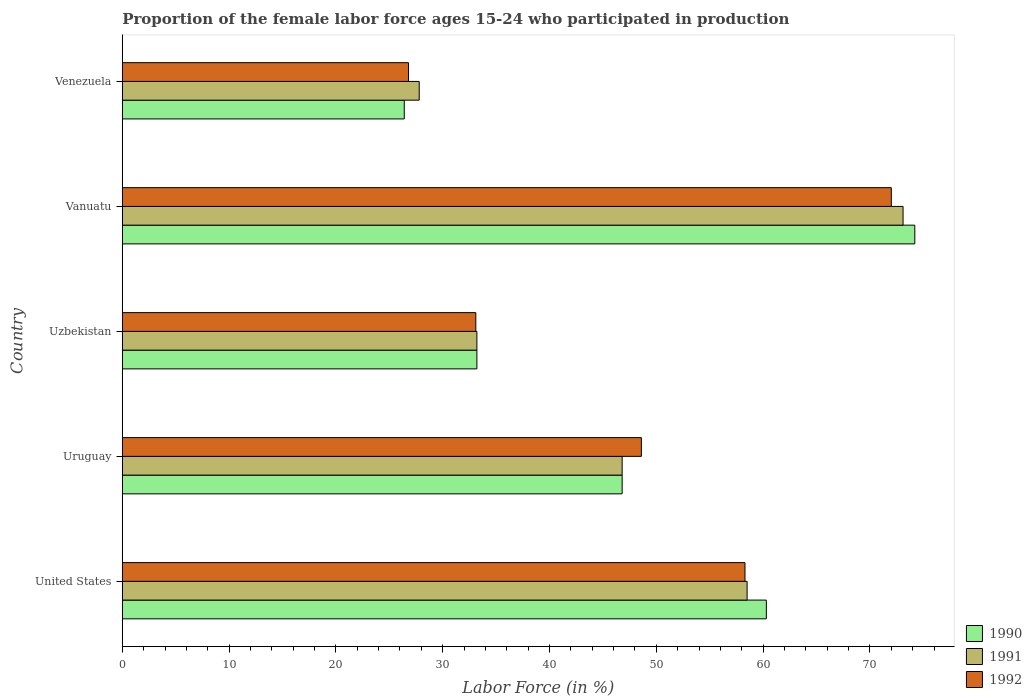Are the number of bars on each tick of the Y-axis equal?
Provide a short and direct response. Yes. How many bars are there on the 4th tick from the bottom?
Ensure brevity in your answer.  3. What is the label of the 4th group of bars from the top?
Your response must be concise. Uruguay. What is the proportion of the female labor force who participated in production in 1992 in Uzbekistan?
Provide a succinct answer. 33.1. Across all countries, what is the maximum proportion of the female labor force who participated in production in 1990?
Ensure brevity in your answer.  74.2. Across all countries, what is the minimum proportion of the female labor force who participated in production in 1992?
Provide a short and direct response. 26.8. In which country was the proportion of the female labor force who participated in production in 1992 maximum?
Provide a succinct answer. Vanuatu. In which country was the proportion of the female labor force who participated in production in 1992 minimum?
Your answer should be very brief. Venezuela. What is the total proportion of the female labor force who participated in production in 1991 in the graph?
Offer a terse response. 239.4. What is the difference between the proportion of the female labor force who participated in production in 1991 in Vanuatu and that in Venezuela?
Your answer should be compact. 45.3. What is the difference between the proportion of the female labor force who participated in production in 1992 in United States and the proportion of the female labor force who participated in production in 1991 in Venezuela?
Offer a terse response. 30.5. What is the average proportion of the female labor force who participated in production in 1992 per country?
Make the answer very short. 47.76. What is the difference between the proportion of the female labor force who participated in production in 1991 and proportion of the female labor force who participated in production in 1992 in Uzbekistan?
Your answer should be compact. 0.1. In how many countries, is the proportion of the female labor force who participated in production in 1991 greater than 60 %?
Offer a terse response. 1. What is the ratio of the proportion of the female labor force who participated in production in 1991 in Uruguay to that in Vanuatu?
Your answer should be very brief. 0.64. Is the difference between the proportion of the female labor force who participated in production in 1991 in Uruguay and Venezuela greater than the difference between the proportion of the female labor force who participated in production in 1992 in Uruguay and Venezuela?
Ensure brevity in your answer.  No. What is the difference between the highest and the second highest proportion of the female labor force who participated in production in 1991?
Offer a terse response. 14.6. What is the difference between the highest and the lowest proportion of the female labor force who participated in production in 1992?
Provide a succinct answer. 45.2. In how many countries, is the proportion of the female labor force who participated in production in 1992 greater than the average proportion of the female labor force who participated in production in 1992 taken over all countries?
Ensure brevity in your answer.  3. Is the sum of the proportion of the female labor force who participated in production in 1992 in Uruguay and Vanuatu greater than the maximum proportion of the female labor force who participated in production in 1990 across all countries?
Provide a short and direct response. Yes. Is it the case that in every country, the sum of the proportion of the female labor force who participated in production in 1990 and proportion of the female labor force who participated in production in 1992 is greater than the proportion of the female labor force who participated in production in 1991?
Your answer should be very brief. Yes. How many bars are there?
Your answer should be very brief. 15. How many countries are there in the graph?
Keep it short and to the point. 5. Does the graph contain grids?
Make the answer very short. No. Where does the legend appear in the graph?
Give a very brief answer. Bottom right. How many legend labels are there?
Your answer should be compact. 3. How are the legend labels stacked?
Your answer should be very brief. Vertical. What is the title of the graph?
Offer a very short reply. Proportion of the female labor force ages 15-24 who participated in production. Does "1998" appear as one of the legend labels in the graph?
Give a very brief answer. No. What is the label or title of the X-axis?
Ensure brevity in your answer.  Labor Force (in %). What is the Labor Force (in %) in 1990 in United States?
Ensure brevity in your answer.  60.3. What is the Labor Force (in %) in 1991 in United States?
Provide a succinct answer. 58.5. What is the Labor Force (in %) of 1992 in United States?
Provide a succinct answer. 58.3. What is the Labor Force (in %) of 1990 in Uruguay?
Ensure brevity in your answer.  46.8. What is the Labor Force (in %) of 1991 in Uruguay?
Keep it short and to the point. 46.8. What is the Labor Force (in %) in 1992 in Uruguay?
Keep it short and to the point. 48.6. What is the Labor Force (in %) in 1990 in Uzbekistan?
Make the answer very short. 33.2. What is the Labor Force (in %) in 1991 in Uzbekistan?
Provide a short and direct response. 33.2. What is the Labor Force (in %) of 1992 in Uzbekistan?
Provide a succinct answer. 33.1. What is the Labor Force (in %) in 1990 in Vanuatu?
Your response must be concise. 74.2. What is the Labor Force (in %) in 1991 in Vanuatu?
Ensure brevity in your answer.  73.1. What is the Labor Force (in %) in 1990 in Venezuela?
Make the answer very short. 26.4. What is the Labor Force (in %) of 1991 in Venezuela?
Provide a succinct answer. 27.8. What is the Labor Force (in %) of 1992 in Venezuela?
Make the answer very short. 26.8. Across all countries, what is the maximum Labor Force (in %) of 1990?
Your answer should be compact. 74.2. Across all countries, what is the maximum Labor Force (in %) in 1991?
Keep it short and to the point. 73.1. Across all countries, what is the maximum Labor Force (in %) of 1992?
Give a very brief answer. 72. Across all countries, what is the minimum Labor Force (in %) in 1990?
Make the answer very short. 26.4. Across all countries, what is the minimum Labor Force (in %) in 1991?
Give a very brief answer. 27.8. Across all countries, what is the minimum Labor Force (in %) of 1992?
Offer a terse response. 26.8. What is the total Labor Force (in %) of 1990 in the graph?
Give a very brief answer. 240.9. What is the total Labor Force (in %) in 1991 in the graph?
Offer a terse response. 239.4. What is the total Labor Force (in %) in 1992 in the graph?
Your answer should be very brief. 238.8. What is the difference between the Labor Force (in %) of 1991 in United States and that in Uruguay?
Provide a short and direct response. 11.7. What is the difference between the Labor Force (in %) in 1992 in United States and that in Uruguay?
Provide a short and direct response. 9.7. What is the difference between the Labor Force (in %) of 1990 in United States and that in Uzbekistan?
Your answer should be very brief. 27.1. What is the difference between the Labor Force (in %) of 1991 in United States and that in Uzbekistan?
Give a very brief answer. 25.3. What is the difference between the Labor Force (in %) of 1992 in United States and that in Uzbekistan?
Your response must be concise. 25.2. What is the difference between the Labor Force (in %) in 1991 in United States and that in Vanuatu?
Your answer should be compact. -14.6. What is the difference between the Labor Force (in %) in 1992 in United States and that in Vanuatu?
Your answer should be compact. -13.7. What is the difference between the Labor Force (in %) of 1990 in United States and that in Venezuela?
Your response must be concise. 33.9. What is the difference between the Labor Force (in %) in 1991 in United States and that in Venezuela?
Offer a very short reply. 30.7. What is the difference between the Labor Force (in %) of 1992 in United States and that in Venezuela?
Your answer should be compact. 31.5. What is the difference between the Labor Force (in %) of 1990 in Uruguay and that in Uzbekistan?
Your response must be concise. 13.6. What is the difference between the Labor Force (in %) in 1991 in Uruguay and that in Uzbekistan?
Provide a succinct answer. 13.6. What is the difference between the Labor Force (in %) of 1992 in Uruguay and that in Uzbekistan?
Offer a very short reply. 15.5. What is the difference between the Labor Force (in %) of 1990 in Uruguay and that in Vanuatu?
Keep it short and to the point. -27.4. What is the difference between the Labor Force (in %) of 1991 in Uruguay and that in Vanuatu?
Offer a very short reply. -26.3. What is the difference between the Labor Force (in %) of 1992 in Uruguay and that in Vanuatu?
Provide a short and direct response. -23.4. What is the difference between the Labor Force (in %) in 1990 in Uruguay and that in Venezuela?
Your response must be concise. 20.4. What is the difference between the Labor Force (in %) of 1991 in Uruguay and that in Venezuela?
Your response must be concise. 19. What is the difference between the Labor Force (in %) in 1992 in Uruguay and that in Venezuela?
Give a very brief answer. 21.8. What is the difference between the Labor Force (in %) of 1990 in Uzbekistan and that in Vanuatu?
Your response must be concise. -41. What is the difference between the Labor Force (in %) in 1991 in Uzbekistan and that in Vanuatu?
Your answer should be very brief. -39.9. What is the difference between the Labor Force (in %) in 1992 in Uzbekistan and that in Vanuatu?
Provide a succinct answer. -38.9. What is the difference between the Labor Force (in %) of 1991 in Uzbekistan and that in Venezuela?
Provide a short and direct response. 5.4. What is the difference between the Labor Force (in %) of 1992 in Uzbekistan and that in Venezuela?
Ensure brevity in your answer.  6.3. What is the difference between the Labor Force (in %) of 1990 in Vanuatu and that in Venezuela?
Make the answer very short. 47.8. What is the difference between the Labor Force (in %) of 1991 in Vanuatu and that in Venezuela?
Make the answer very short. 45.3. What is the difference between the Labor Force (in %) of 1992 in Vanuatu and that in Venezuela?
Offer a terse response. 45.2. What is the difference between the Labor Force (in %) of 1991 in United States and the Labor Force (in %) of 1992 in Uruguay?
Make the answer very short. 9.9. What is the difference between the Labor Force (in %) of 1990 in United States and the Labor Force (in %) of 1991 in Uzbekistan?
Offer a terse response. 27.1. What is the difference between the Labor Force (in %) in 1990 in United States and the Labor Force (in %) in 1992 in Uzbekistan?
Offer a very short reply. 27.2. What is the difference between the Labor Force (in %) in 1991 in United States and the Labor Force (in %) in 1992 in Uzbekistan?
Ensure brevity in your answer.  25.4. What is the difference between the Labor Force (in %) in 1990 in United States and the Labor Force (in %) in 1991 in Venezuela?
Your answer should be compact. 32.5. What is the difference between the Labor Force (in %) in 1990 in United States and the Labor Force (in %) in 1992 in Venezuela?
Provide a short and direct response. 33.5. What is the difference between the Labor Force (in %) of 1991 in United States and the Labor Force (in %) of 1992 in Venezuela?
Your response must be concise. 31.7. What is the difference between the Labor Force (in %) of 1990 in Uruguay and the Labor Force (in %) of 1991 in Uzbekistan?
Offer a terse response. 13.6. What is the difference between the Labor Force (in %) in 1990 in Uruguay and the Labor Force (in %) in 1991 in Vanuatu?
Ensure brevity in your answer.  -26.3. What is the difference between the Labor Force (in %) of 1990 in Uruguay and the Labor Force (in %) of 1992 in Vanuatu?
Offer a terse response. -25.2. What is the difference between the Labor Force (in %) in 1991 in Uruguay and the Labor Force (in %) in 1992 in Vanuatu?
Your response must be concise. -25.2. What is the difference between the Labor Force (in %) in 1990 in Uruguay and the Labor Force (in %) in 1991 in Venezuela?
Your answer should be compact. 19. What is the difference between the Labor Force (in %) of 1990 in Uruguay and the Labor Force (in %) of 1992 in Venezuela?
Provide a short and direct response. 20. What is the difference between the Labor Force (in %) in 1990 in Uzbekistan and the Labor Force (in %) in 1991 in Vanuatu?
Provide a succinct answer. -39.9. What is the difference between the Labor Force (in %) of 1990 in Uzbekistan and the Labor Force (in %) of 1992 in Vanuatu?
Your response must be concise. -38.8. What is the difference between the Labor Force (in %) in 1991 in Uzbekistan and the Labor Force (in %) in 1992 in Vanuatu?
Your response must be concise. -38.8. What is the difference between the Labor Force (in %) of 1990 in Uzbekistan and the Labor Force (in %) of 1992 in Venezuela?
Keep it short and to the point. 6.4. What is the difference between the Labor Force (in %) of 1990 in Vanuatu and the Labor Force (in %) of 1991 in Venezuela?
Offer a terse response. 46.4. What is the difference between the Labor Force (in %) in 1990 in Vanuatu and the Labor Force (in %) in 1992 in Venezuela?
Your answer should be very brief. 47.4. What is the difference between the Labor Force (in %) of 1991 in Vanuatu and the Labor Force (in %) of 1992 in Venezuela?
Make the answer very short. 46.3. What is the average Labor Force (in %) of 1990 per country?
Provide a short and direct response. 48.18. What is the average Labor Force (in %) in 1991 per country?
Your answer should be compact. 47.88. What is the average Labor Force (in %) in 1992 per country?
Give a very brief answer. 47.76. What is the difference between the Labor Force (in %) of 1990 and Labor Force (in %) of 1991 in United States?
Offer a very short reply. 1.8. What is the difference between the Labor Force (in %) in 1990 and Labor Force (in %) in 1992 in United States?
Provide a succinct answer. 2. What is the difference between the Labor Force (in %) in 1991 and Labor Force (in %) in 1992 in United States?
Your response must be concise. 0.2. What is the difference between the Labor Force (in %) in 1990 and Labor Force (in %) in 1991 in Uruguay?
Your answer should be compact. 0. What is the difference between the Labor Force (in %) in 1990 and Labor Force (in %) in 1992 in Uruguay?
Provide a short and direct response. -1.8. What is the difference between the Labor Force (in %) in 1991 and Labor Force (in %) in 1992 in Uruguay?
Your answer should be compact. -1.8. What is the difference between the Labor Force (in %) in 1990 and Labor Force (in %) in 1991 in Uzbekistan?
Offer a very short reply. 0. What is the difference between the Labor Force (in %) in 1991 and Labor Force (in %) in 1992 in Uzbekistan?
Your response must be concise. 0.1. What is the difference between the Labor Force (in %) of 1990 and Labor Force (in %) of 1991 in Vanuatu?
Offer a very short reply. 1.1. What is the difference between the Labor Force (in %) of 1991 and Labor Force (in %) of 1992 in Vanuatu?
Your answer should be compact. 1.1. What is the difference between the Labor Force (in %) in 1990 and Labor Force (in %) in 1991 in Venezuela?
Your answer should be compact. -1.4. What is the difference between the Labor Force (in %) in 1990 and Labor Force (in %) in 1992 in Venezuela?
Provide a short and direct response. -0.4. What is the ratio of the Labor Force (in %) of 1990 in United States to that in Uruguay?
Offer a terse response. 1.29. What is the ratio of the Labor Force (in %) in 1991 in United States to that in Uruguay?
Your answer should be compact. 1.25. What is the ratio of the Labor Force (in %) in 1992 in United States to that in Uruguay?
Provide a succinct answer. 1.2. What is the ratio of the Labor Force (in %) in 1990 in United States to that in Uzbekistan?
Provide a succinct answer. 1.82. What is the ratio of the Labor Force (in %) in 1991 in United States to that in Uzbekistan?
Give a very brief answer. 1.76. What is the ratio of the Labor Force (in %) of 1992 in United States to that in Uzbekistan?
Your response must be concise. 1.76. What is the ratio of the Labor Force (in %) in 1990 in United States to that in Vanuatu?
Your answer should be compact. 0.81. What is the ratio of the Labor Force (in %) in 1991 in United States to that in Vanuatu?
Provide a succinct answer. 0.8. What is the ratio of the Labor Force (in %) in 1992 in United States to that in Vanuatu?
Your answer should be compact. 0.81. What is the ratio of the Labor Force (in %) in 1990 in United States to that in Venezuela?
Your response must be concise. 2.28. What is the ratio of the Labor Force (in %) of 1991 in United States to that in Venezuela?
Your answer should be compact. 2.1. What is the ratio of the Labor Force (in %) in 1992 in United States to that in Venezuela?
Ensure brevity in your answer.  2.18. What is the ratio of the Labor Force (in %) of 1990 in Uruguay to that in Uzbekistan?
Keep it short and to the point. 1.41. What is the ratio of the Labor Force (in %) of 1991 in Uruguay to that in Uzbekistan?
Ensure brevity in your answer.  1.41. What is the ratio of the Labor Force (in %) of 1992 in Uruguay to that in Uzbekistan?
Make the answer very short. 1.47. What is the ratio of the Labor Force (in %) in 1990 in Uruguay to that in Vanuatu?
Give a very brief answer. 0.63. What is the ratio of the Labor Force (in %) of 1991 in Uruguay to that in Vanuatu?
Make the answer very short. 0.64. What is the ratio of the Labor Force (in %) of 1992 in Uruguay to that in Vanuatu?
Provide a succinct answer. 0.68. What is the ratio of the Labor Force (in %) of 1990 in Uruguay to that in Venezuela?
Provide a succinct answer. 1.77. What is the ratio of the Labor Force (in %) of 1991 in Uruguay to that in Venezuela?
Provide a short and direct response. 1.68. What is the ratio of the Labor Force (in %) in 1992 in Uruguay to that in Venezuela?
Offer a very short reply. 1.81. What is the ratio of the Labor Force (in %) in 1990 in Uzbekistan to that in Vanuatu?
Offer a terse response. 0.45. What is the ratio of the Labor Force (in %) of 1991 in Uzbekistan to that in Vanuatu?
Your answer should be very brief. 0.45. What is the ratio of the Labor Force (in %) in 1992 in Uzbekistan to that in Vanuatu?
Make the answer very short. 0.46. What is the ratio of the Labor Force (in %) of 1990 in Uzbekistan to that in Venezuela?
Keep it short and to the point. 1.26. What is the ratio of the Labor Force (in %) in 1991 in Uzbekistan to that in Venezuela?
Offer a terse response. 1.19. What is the ratio of the Labor Force (in %) of 1992 in Uzbekistan to that in Venezuela?
Give a very brief answer. 1.24. What is the ratio of the Labor Force (in %) of 1990 in Vanuatu to that in Venezuela?
Keep it short and to the point. 2.81. What is the ratio of the Labor Force (in %) in 1991 in Vanuatu to that in Venezuela?
Your response must be concise. 2.63. What is the ratio of the Labor Force (in %) in 1992 in Vanuatu to that in Venezuela?
Your answer should be very brief. 2.69. What is the difference between the highest and the lowest Labor Force (in %) of 1990?
Make the answer very short. 47.8. What is the difference between the highest and the lowest Labor Force (in %) in 1991?
Your answer should be compact. 45.3. What is the difference between the highest and the lowest Labor Force (in %) of 1992?
Give a very brief answer. 45.2. 